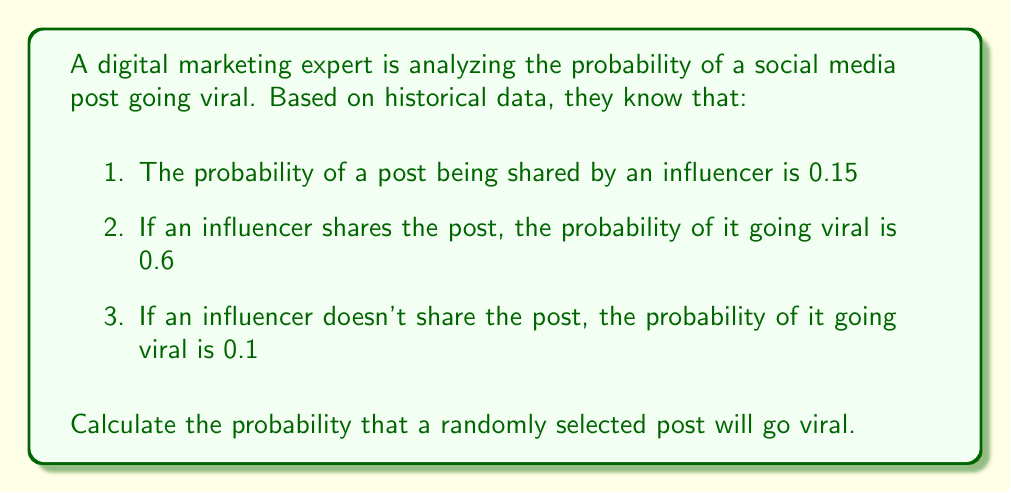What is the answer to this math problem? To solve this problem, we can use the law of total probability. Let's define our events:

$A$: The post goes viral
$B$: The post is shared by an influencer

We're given:
$P(B) = 0.15$
$P(A|B) = 0.6$
$P(A|\text{not }B) = 0.1$

The law of total probability states:

$$P(A) = P(A|B) \cdot P(B) + P(A|\text{not }B) \cdot P(\text{not }B)$$

We know $P(B) = 0.15$, so $P(\text{not }B) = 1 - 0.15 = 0.85$

Now, let's substitute the values into the formula:

$$\begin{align}
P(A) &= P(A|B) \cdot P(B) + P(A|\text{not }B) \cdot P(\text{not }B) \\
&= 0.6 \cdot 0.15 + 0.1 \cdot 0.85 \\
&= 0.09 + 0.085 \\
&= 0.175
\end{align}$$

Therefore, the probability that a randomly selected post will go viral is 0.175 or 17.5%.
Answer: The probability that a randomly selected post will go viral is 0.175 or 17.5%. 